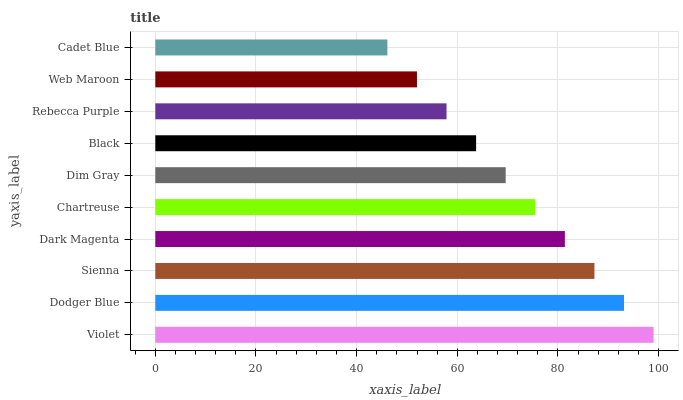Is Cadet Blue the minimum?
Answer yes or no. Yes. Is Violet the maximum?
Answer yes or no. Yes. Is Dodger Blue the minimum?
Answer yes or no. No. Is Dodger Blue the maximum?
Answer yes or no. No. Is Violet greater than Dodger Blue?
Answer yes or no. Yes. Is Dodger Blue less than Violet?
Answer yes or no. Yes. Is Dodger Blue greater than Violet?
Answer yes or no. No. Is Violet less than Dodger Blue?
Answer yes or no. No. Is Chartreuse the high median?
Answer yes or no. Yes. Is Dim Gray the low median?
Answer yes or no. Yes. Is Sienna the high median?
Answer yes or no. No. Is Dodger Blue the low median?
Answer yes or no. No. 